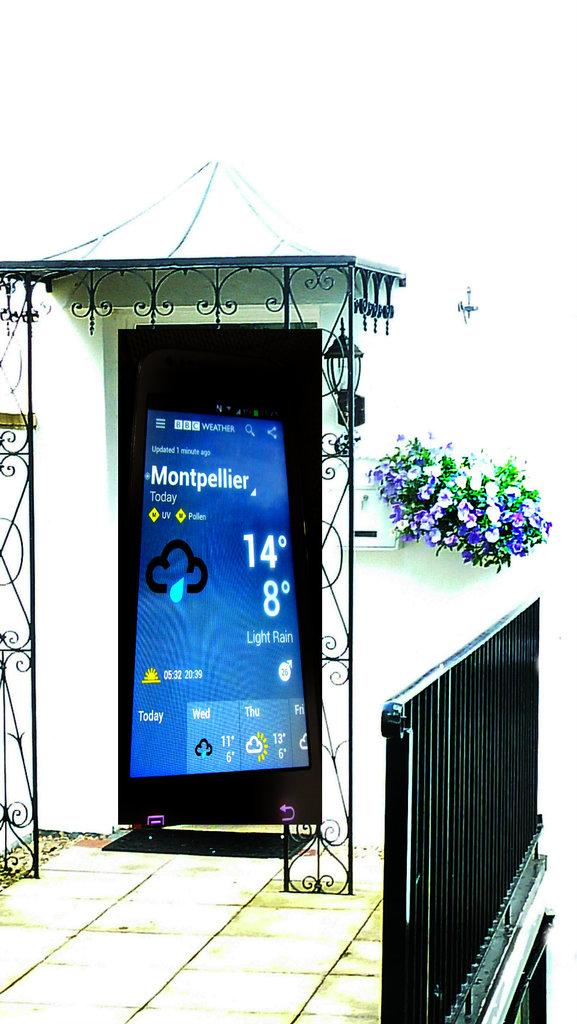<image>
Create a compact narrative representing the image presented. A large display showing the weather forecast in Montpellier 